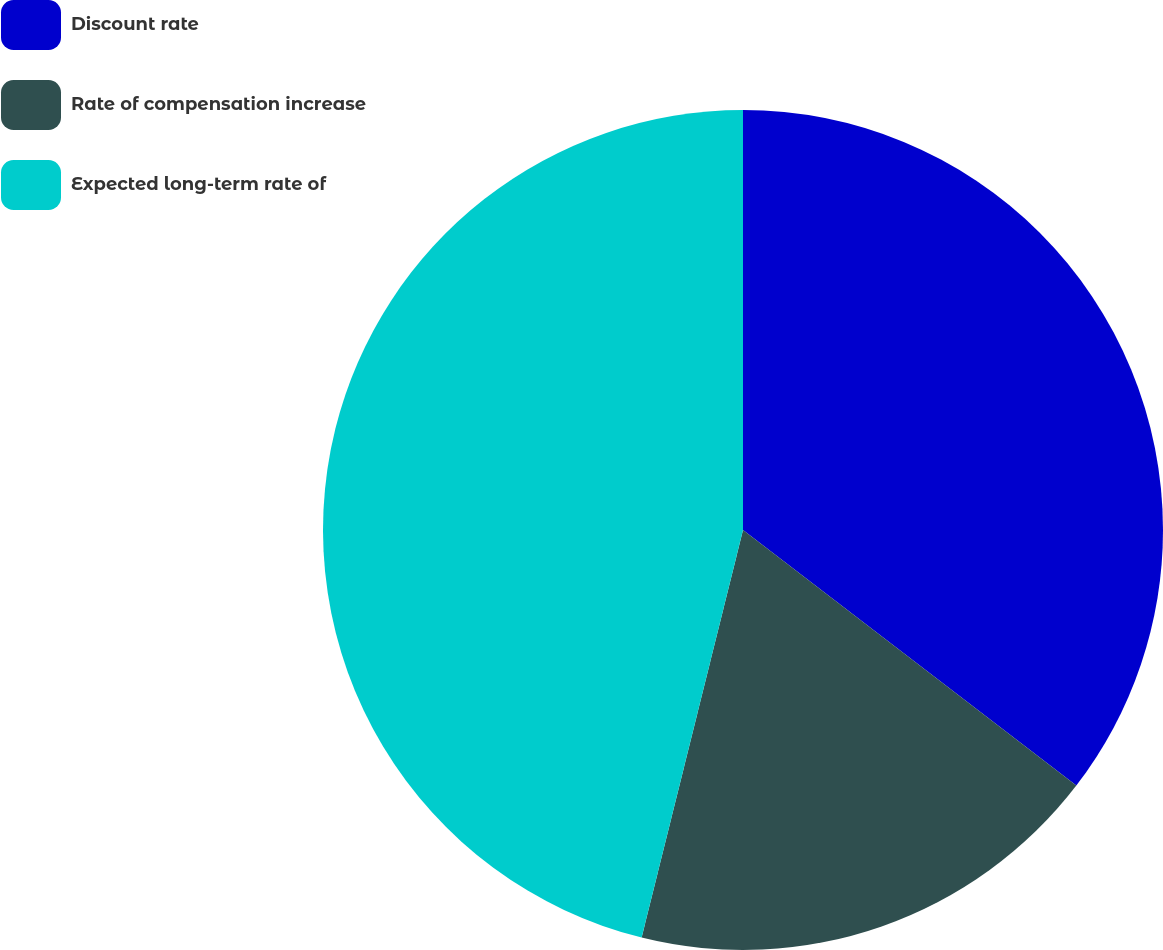Convert chart. <chart><loc_0><loc_0><loc_500><loc_500><pie_chart><fcel>Discount rate<fcel>Rate of compensation increase<fcel>Expected long-term rate of<nl><fcel>35.41%<fcel>18.47%<fcel>46.12%<nl></chart> 